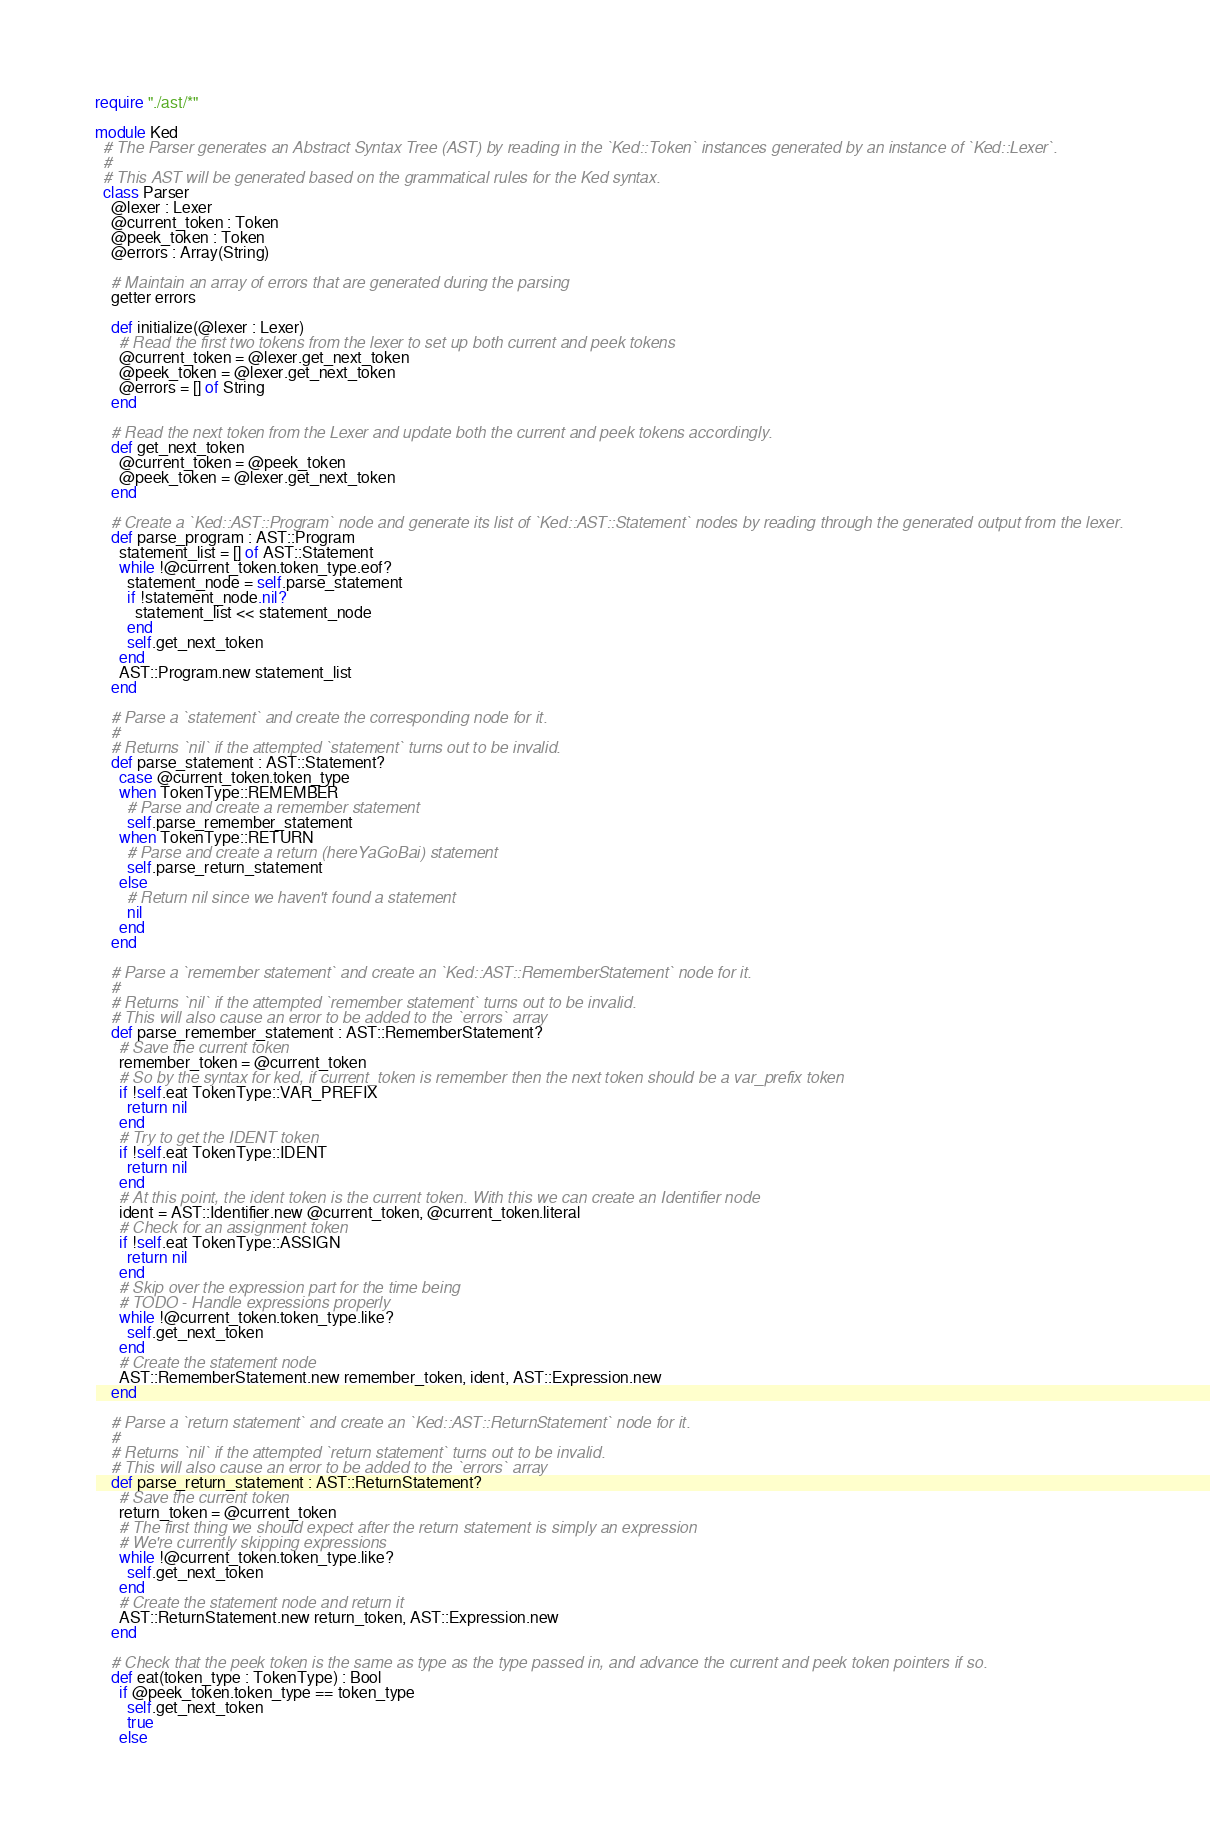Convert code to text. <code><loc_0><loc_0><loc_500><loc_500><_Crystal_>require "./ast/*"

module Ked
  # The Parser generates an Abstract Syntax Tree (AST) by reading in the `Ked::Token` instances generated by an instance of `Ked::Lexer`.
  #
  # This AST will be generated based on the grammatical rules for the Ked syntax.
  class Parser
    @lexer : Lexer
    @current_token : Token
    @peek_token : Token
    @errors : Array(String)

    # Maintain an array of errors that are generated during the parsing
    getter errors

    def initialize(@lexer : Lexer)
      # Read the first two tokens from the lexer to set up both current and peek tokens
      @current_token = @lexer.get_next_token
      @peek_token = @lexer.get_next_token
      @errors = [] of String
    end

    # Read the next token from the Lexer and update both the current and peek tokens accordingly.
    def get_next_token
      @current_token = @peek_token
      @peek_token = @lexer.get_next_token
    end

    # Create a `Ked::AST::Program` node and generate its list of `Ked::AST::Statement` nodes by reading through the generated output from the lexer.
    def parse_program : AST::Program
      statement_list = [] of AST::Statement
      while !@current_token.token_type.eof?
        statement_node = self.parse_statement
        if !statement_node.nil?
          statement_list << statement_node
        end
        self.get_next_token
      end
      AST::Program.new statement_list
    end

    # Parse a `statement` and create the corresponding node for it.
    #
    # Returns `nil` if the attempted `statement` turns out to be invalid.
    def parse_statement : AST::Statement?
      case @current_token.token_type
      when TokenType::REMEMBER
        # Parse and create a remember statement
        self.parse_remember_statement
      when TokenType::RETURN
        # Parse and create a return (hereYaGoBai) statement
        self.parse_return_statement
      else
        # Return nil since we haven't found a statement
        nil
      end
    end

    # Parse a `remember statement` and create an `Ked::AST::RememberStatement` node for it.
    #
    # Returns `nil` if the attempted `remember statement` turns out to be invalid.
    # This will also cause an error to be added to the `errors` array
    def parse_remember_statement : AST::RememberStatement?
      # Save the current token
      remember_token = @current_token
      # So by the syntax for ked, if current_token is remember then the next token should be a var_prefix token
      if !self.eat TokenType::VAR_PREFIX
        return nil
      end
      # Try to get the IDENT token
      if !self.eat TokenType::IDENT
        return nil
      end
      # At this point, the ident token is the current token. With this we can create an Identifier node
      ident = AST::Identifier.new @current_token, @current_token.literal
      # Check for an assignment token
      if !self.eat TokenType::ASSIGN
        return nil
      end
      # Skip over the expression part for the time being
      # TODO - Handle expressions properly
      while !@current_token.token_type.like?
        self.get_next_token
      end
      # Create the statement node
      AST::RememberStatement.new remember_token, ident, AST::Expression.new
    end

    # Parse a `return statement` and create an `Ked::AST::ReturnStatement` node for it.
    #
    # Returns `nil` if the attempted `return statement` turns out to be invalid.
    # This will also cause an error to be added to the `errors` array
    def parse_return_statement : AST::ReturnStatement?
      # Save the current token
      return_token = @current_token
      # The first thing we should expect after the return statement is simply an expression
      # We're currently skipping expressions
      while !@current_token.token_type.like?
        self.get_next_token
      end
      # Create the statement node and return it
      AST::ReturnStatement.new return_token, AST::Expression.new
    end

    # Check that the peek token is the same as type as the type passed in, and advance the current and peek token pointers if so.
    def eat(token_type : TokenType) : Bool
      if @peek_token.token_type == token_type
        self.get_next_token
        true
      else</code> 